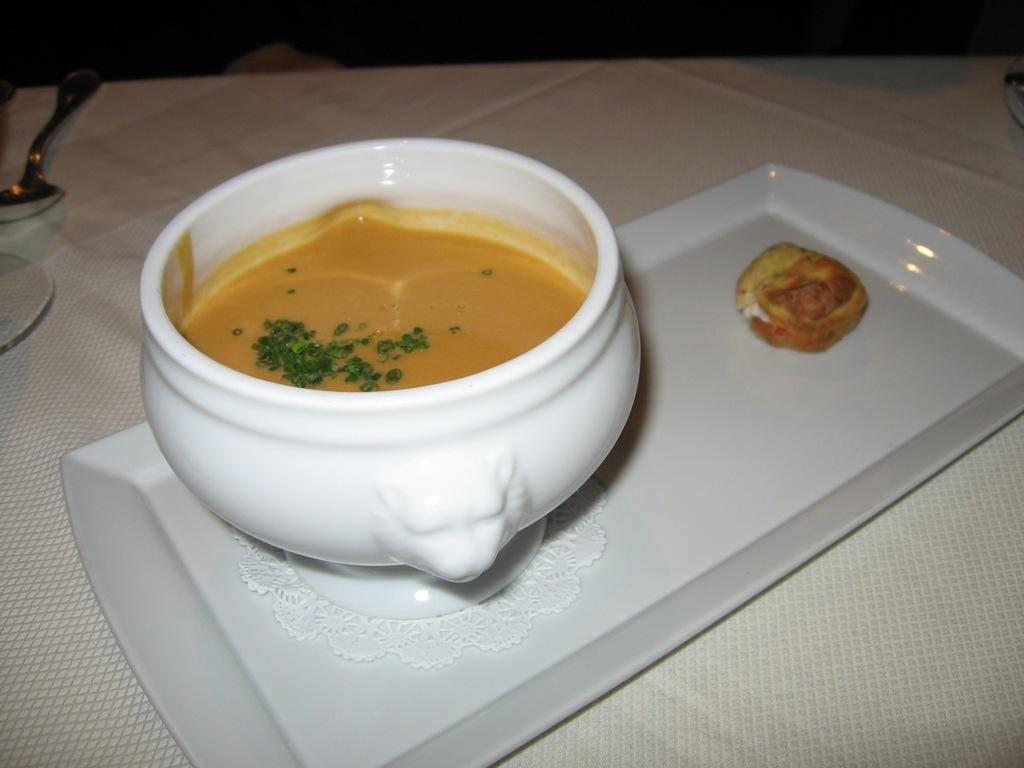Please provide a concise description of this image. In this picture we can see a bowl and food items on a tray and these all are placed on a table. 